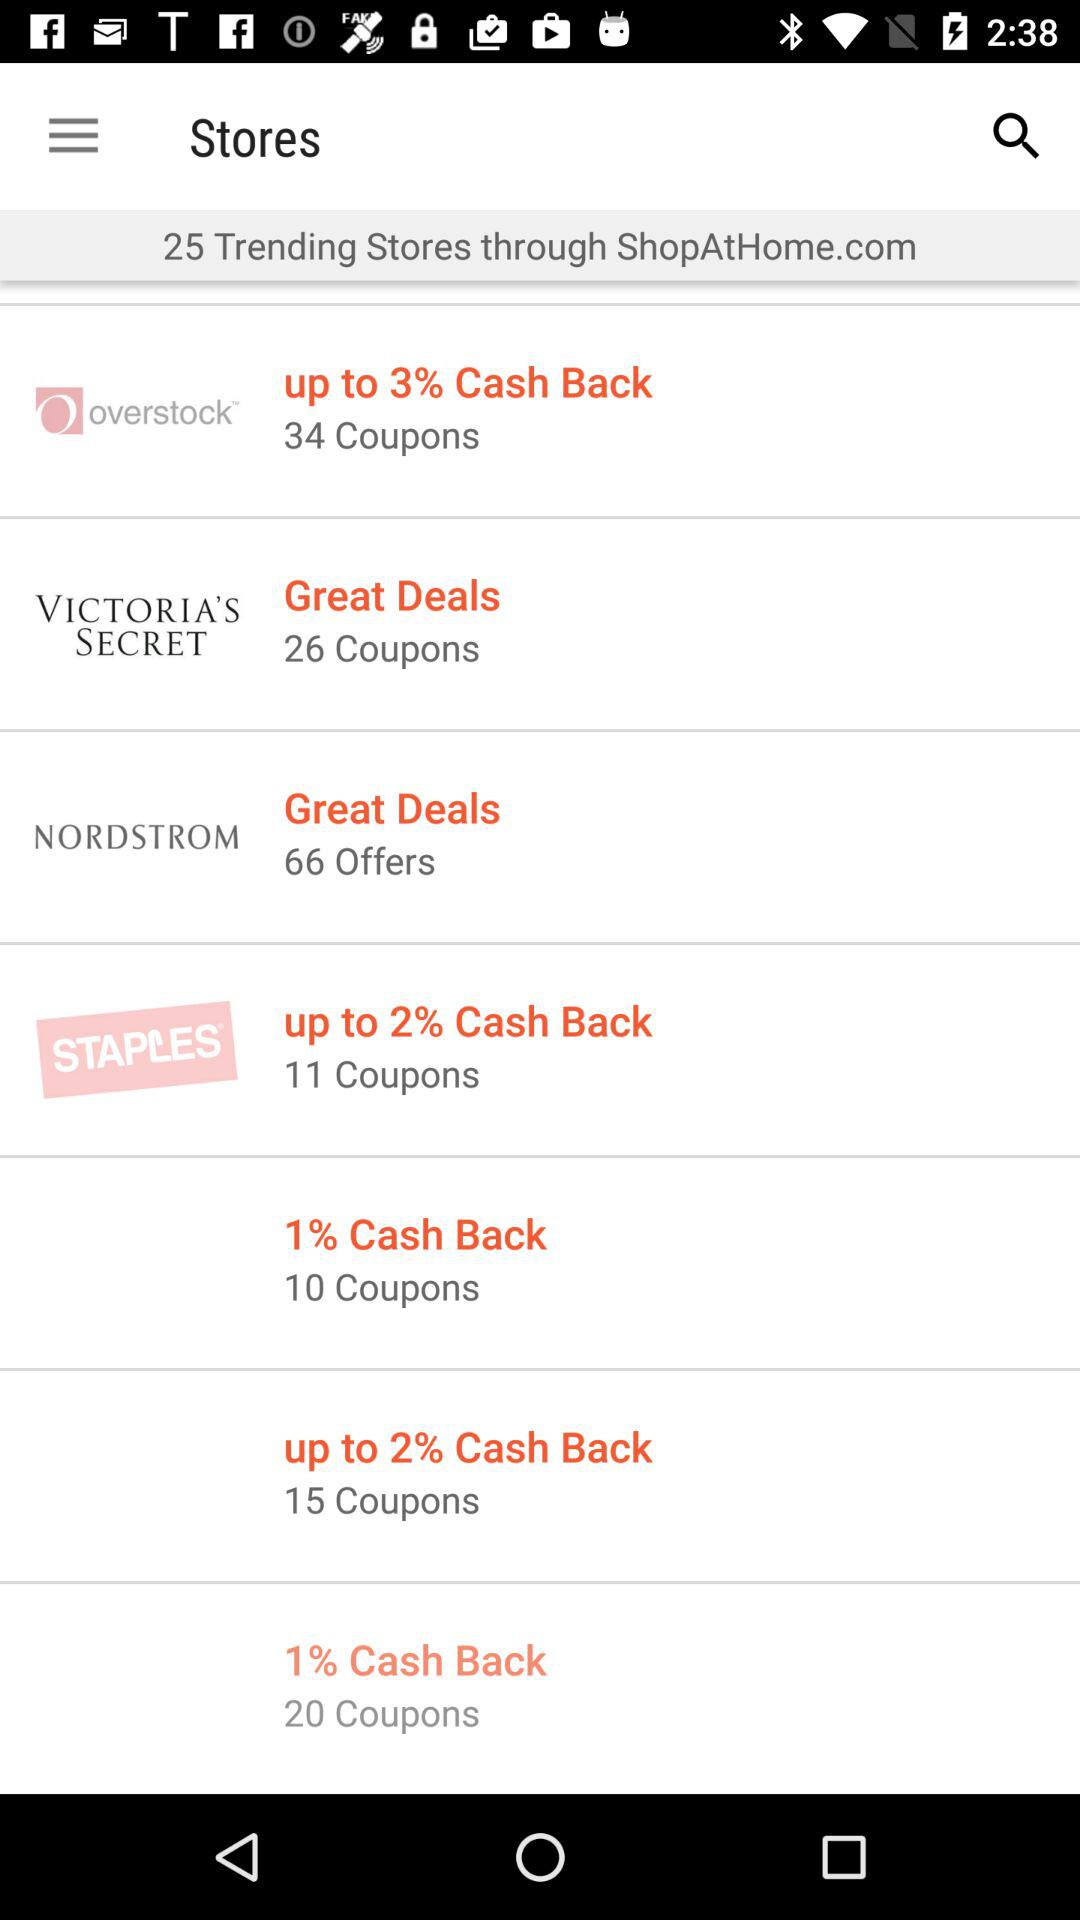What is the cashback on "overstock"? The cashback on "overstock" is up to 3%. 